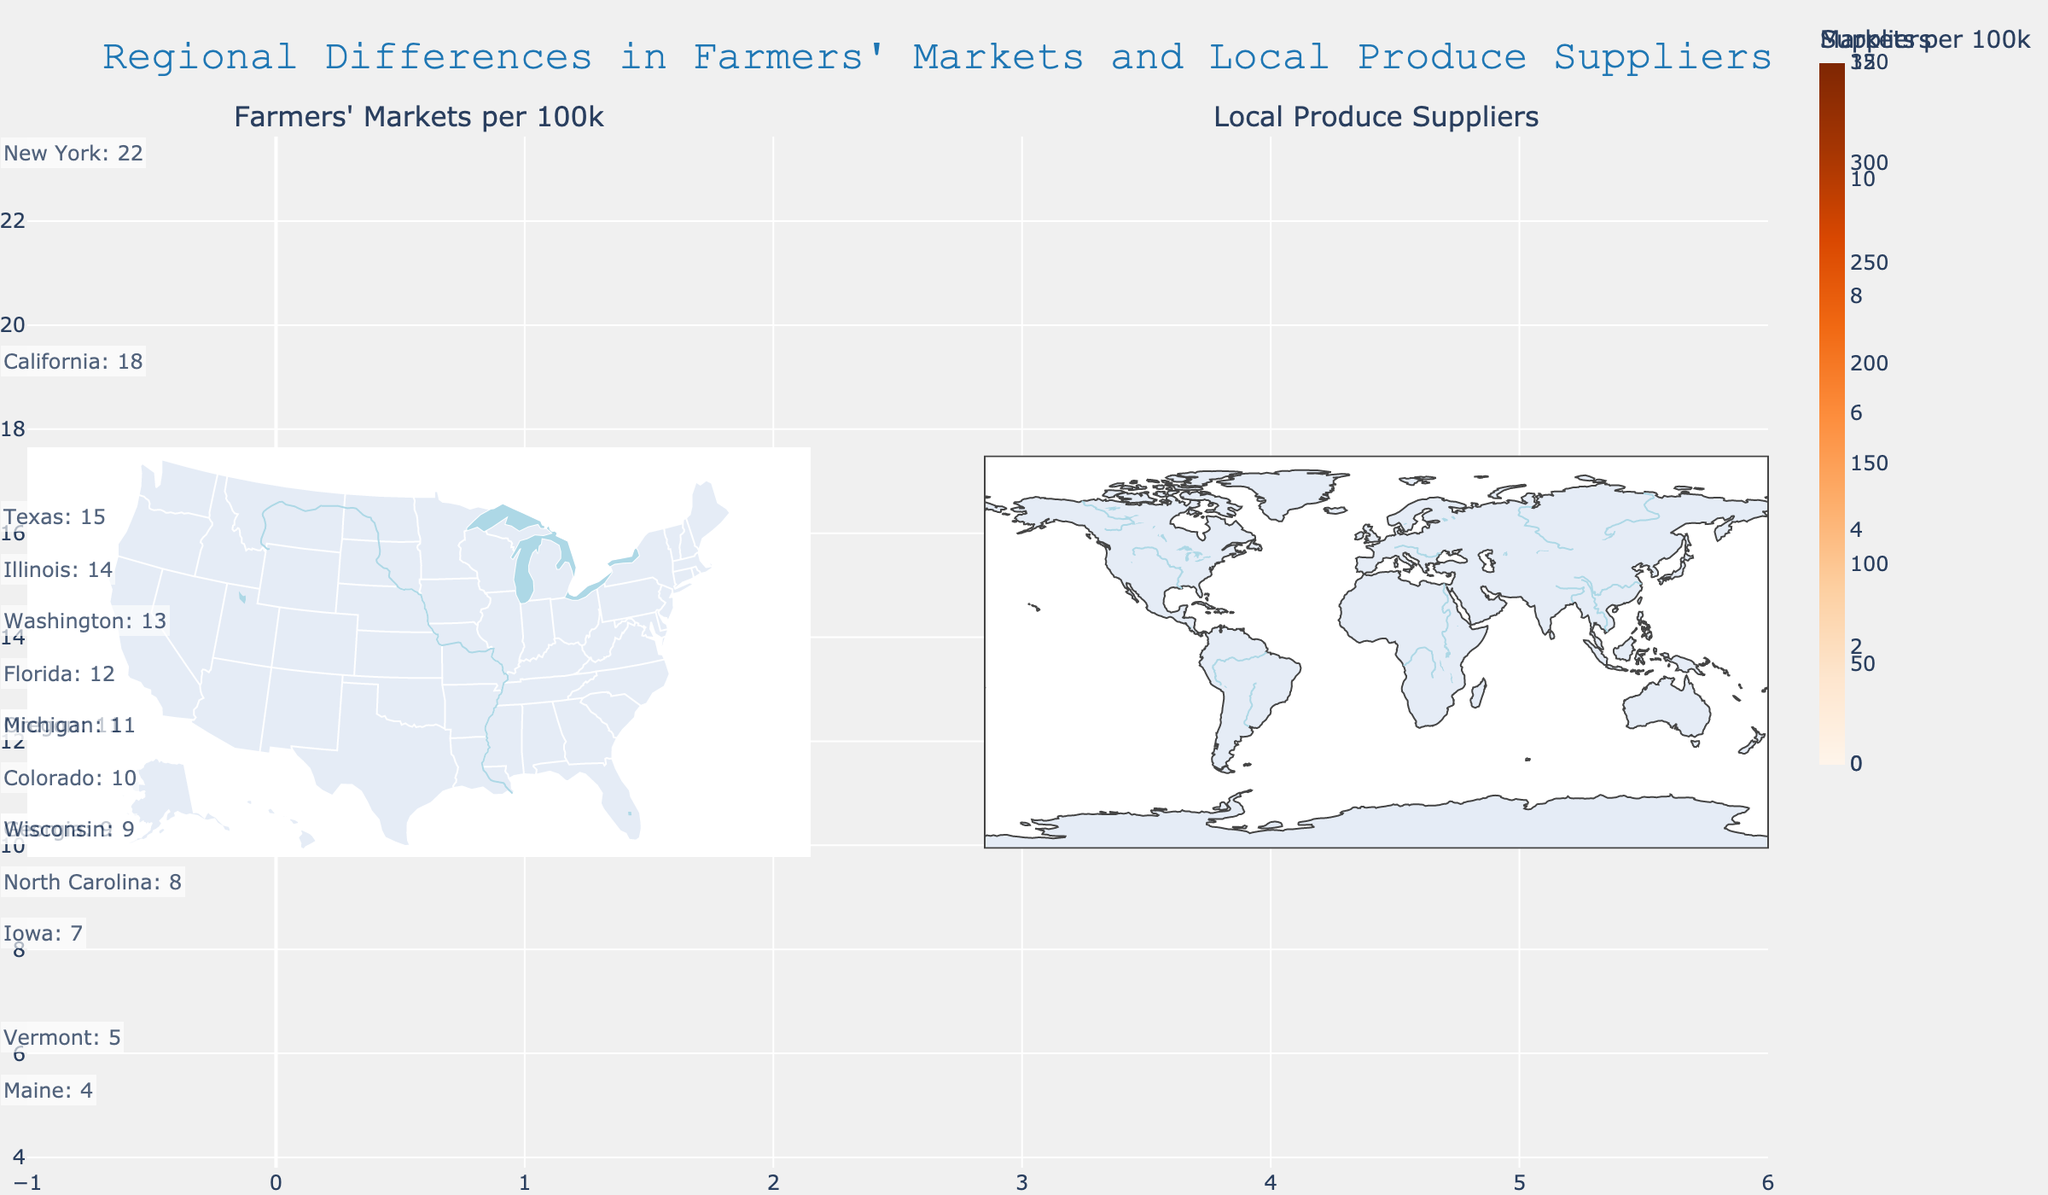What is the color scheme used for representing Farmers' Markets per 100k? The Farmers' Markets per 100k are shown using a Viridis color scale, which ranges from dark to bright colors. The legend related to Farmers' Markets indicates this color scheme.
Answer: Viridis Which state has the highest number of Local Produce Suppliers? California shows the highest z-value (312) on the color scale for Local Produce Suppliers based on the map's legend for the Local Produce Suppliers choropleth.
Answer: California How many states have Homemade Meal Delivery Services values explicitly annotated on the map? The question requires observing all states and counting the explicit annotations provided for Homemade Meal Delivery Services. There are 15 states with these annotations including Vermont, California, Florida, Texas, New York, Iowa, Oregon, Georgia, Maine, Illinois, Colorado, Washington, North Carolina, Michigan, and Wisconsin.
Answer: 15 Compare the Farmers' Markets per 100k between Oregon and Iowa. Which state has more? By looking at the color scale and values on the Farmers' Markets map, we see that Oregon has 9.3 Farmers' Markets per 100k, whereas Iowa has 8.7. Oregon has slightly more.
Answer: Oregon What is the sum of Homemade Meal Delivery Services in Vermont, Maine, and Wisconsin? Vermont has 5, Maine has 4, and Wisconsin has 9 Homemade Meal Delivery Services. Summing these: 5 + 4 + 9 = 18.
Answer: 18 In terms of Farmers' Markets per 100k, which state has the closest value to New York? New York has 5.6 Farmers' Markets per 100k. Wisconsin, with 7.4, is the closest when comparing the remaining values where Iowa has 8.7, Michigan has 5.9, Illinois has 4.8, etc.
Answer: Michigan 